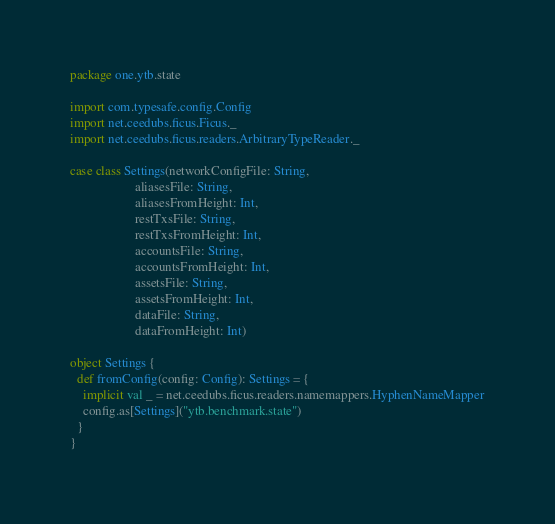<code> <loc_0><loc_0><loc_500><loc_500><_Scala_>package one.ytb.state

import com.typesafe.config.Config
import net.ceedubs.ficus.Ficus._
import net.ceedubs.ficus.readers.ArbitraryTypeReader._

case class Settings(networkConfigFile: String,
                    aliasesFile: String,
                    aliasesFromHeight: Int,
                    restTxsFile: String,
                    restTxsFromHeight: Int,
                    accountsFile: String,
                    accountsFromHeight: Int,
                    assetsFile: String,
                    assetsFromHeight: Int,
                    dataFile: String,
                    dataFromHeight: Int)

object Settings {
  def fromConfig(config: Config): Settings = {
    implicit val _ = net.ceedubs.ficus.readers.namemappers.HyphenNameMapper
    config.as[Settings]("ytb.benchmark.state")
  }
}
</code> 